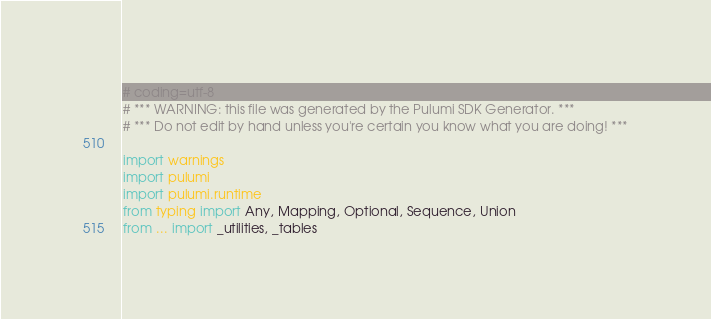<code> <loc_0><loc_0><loc_500><loc_500><_Python_># coding=utf-8
# *** WARNING: this file was generated by the Pulumi SDK Generator. ***
# *** Do not edit by hand unless you're certain you know what you are doing! ***

import warnings
import pulumi
import pulumi.runtime
from typing import Any, Mapping, Optional, Sequence, Union
from ... import _utilities, _tables</code> 